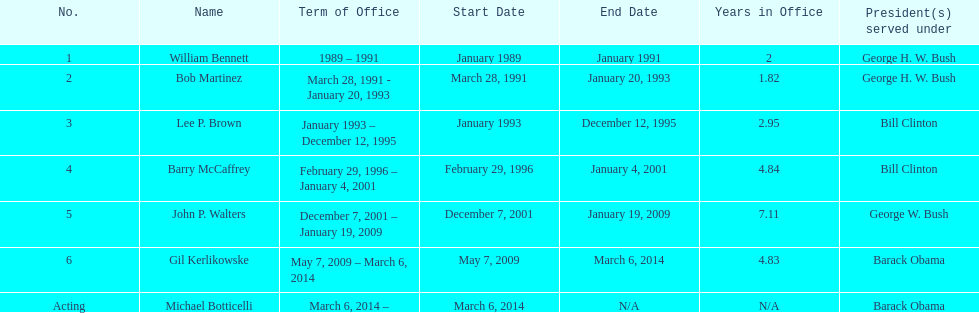How many directors served more than 3 years? 3. 